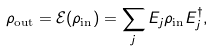<formula> <loc_0><loc_0><loc_500><loc_500>\rho _ { \text {out} } = \mathcal { E } ( \rho _ { \text {in} } ) = \sum _ { j } E _ { j } \rho _ { \text {in} } E _ { j } ^ { \dagger } ,</formula> 